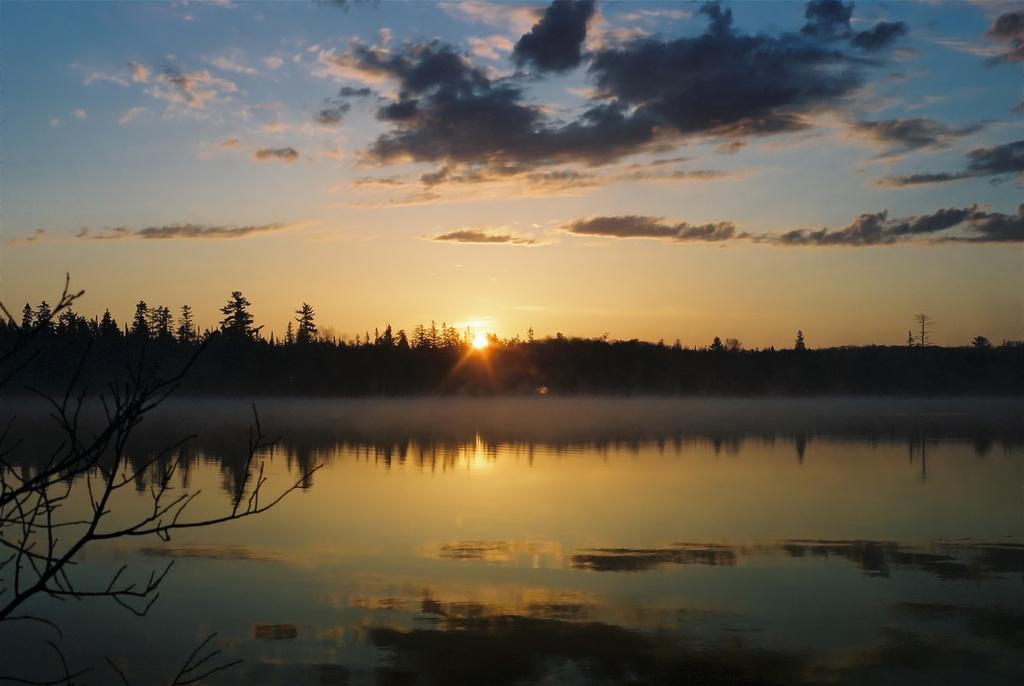What is the primary element visible in the image? There is water in the image. What type of vegetation can be seen in the image? There are trees in the image. What is the source of light in the background of the image? The background of the image includes sunlight. What can be seen in the sky in the image? Clouds are present in the sky. How many fish are visible in the can in the image? There are no fish or cans present in the image; it features water, trees, sunlight, and clouds. 